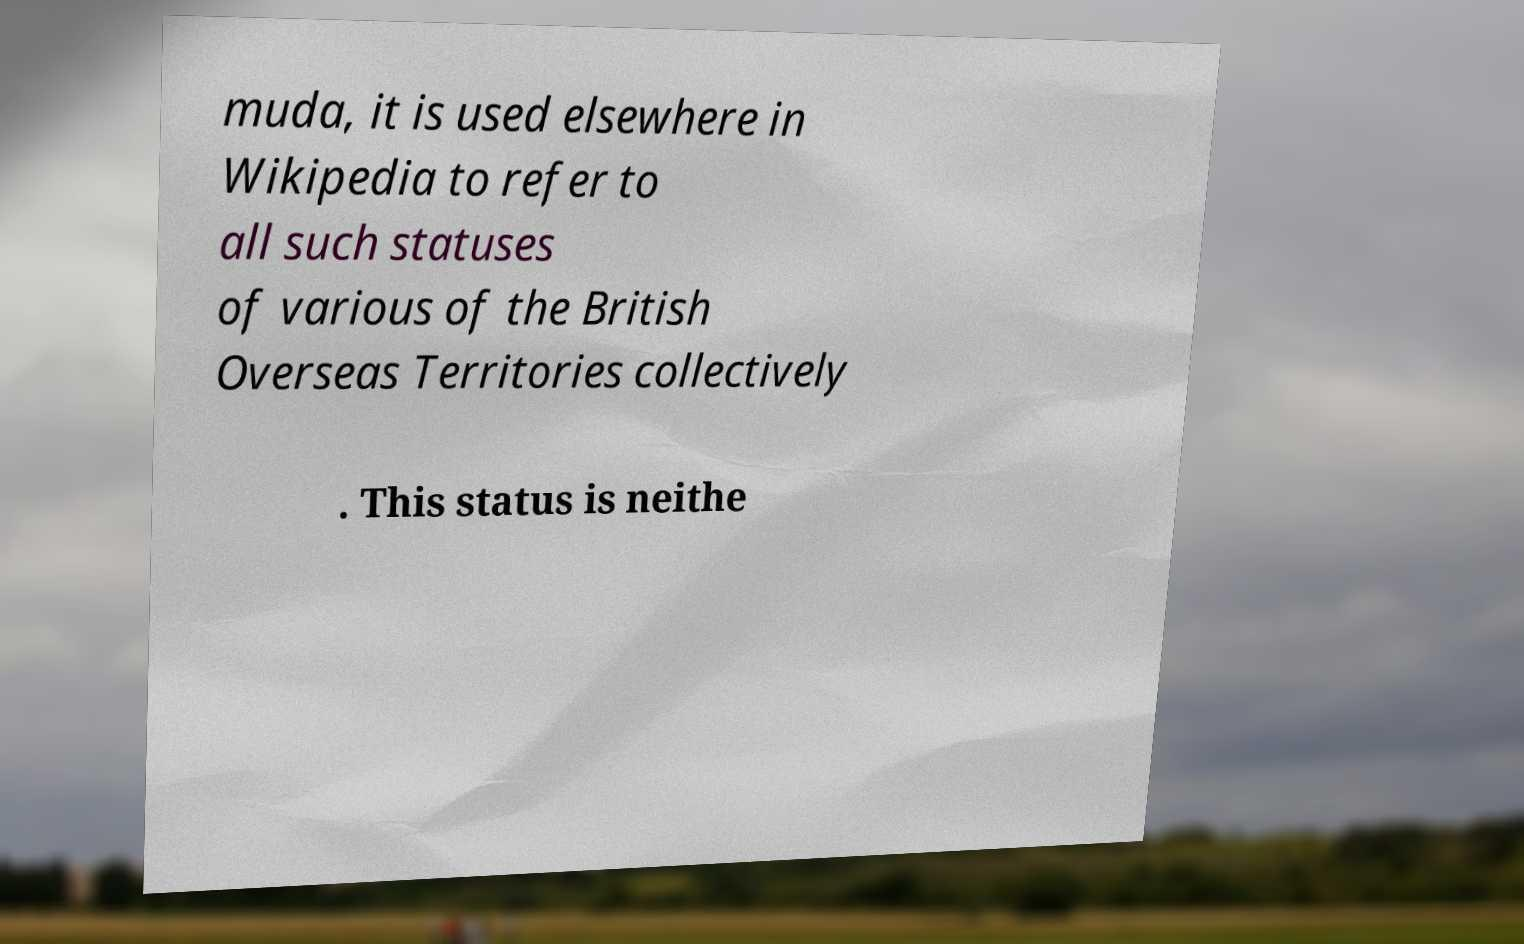I need the written content from this picture converted into text. Can you do that? muda, it is used elsewhere in Wikipedia to refer to all such statuses of various of the British Overseas Territories collectively . This status is neithe 